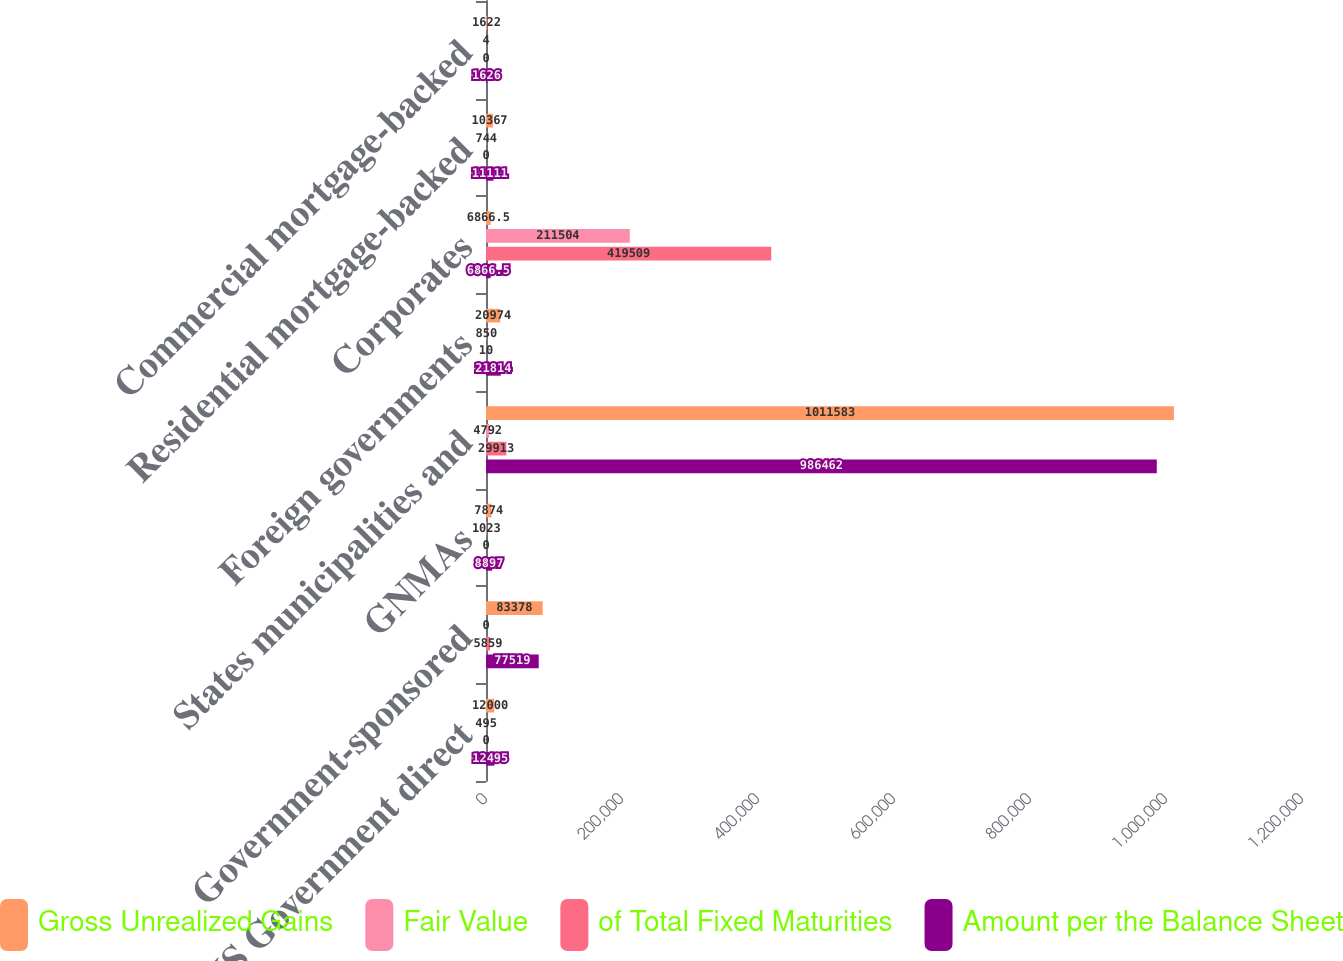<chart> <loc_0><loc_0><loc_500><loc_500><stacked_bar_chart><ecel><fcel>US Government direct<fcel>Government-sponsored<fcel>GNMAs<fcel>States municipalities and<fcel>Foreign governments<fcel>Corporates<fcel>Residential mortgage-backed<fcel>Commercial mortgage-backed<nl><fcel>Gross Unrealized Gains<fcel>12000<fcel>83378<fcel>7874<fcel>1.01158e+06<fcel>20974<fcel>6866.5<fcel>10367<fcel>1622<nl><fcel>Fair Value<fcel>495<fcel>0<fcel>1023<fcel>4792<fcel>850<fcel>211504<fcel>744<fcel>4<nl><fcel>of Total Fixed Maturities<fcel>0<fcel>5859<fcel>0<fcel>29913<fcel>10<fcel>419509<fcel>0<fcel>0<nl><fcel>Amount per the Balance Sheet<fcel>12495<fcel>77519<fcel>8897<fcel>986462<fcel>21814<fcel>6866.5<fcel>11111<fcel>1626<nl></chart> 